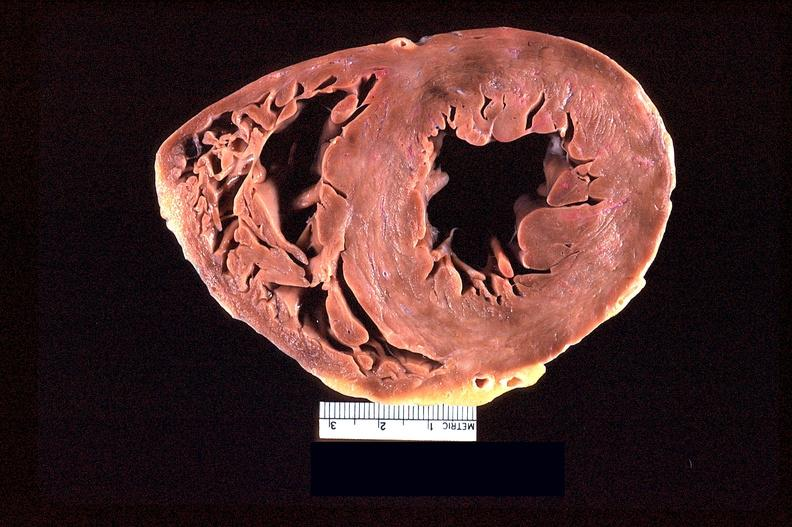does cachexia show heart slice, acute posterior myocardial infarction in patient with hypertension?
Answer the question using a single word or phrase. No 